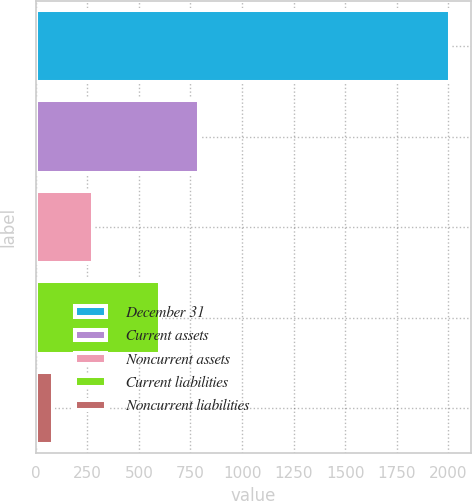Convert chart to OTSL. <chart><loc_0><loc_0><loc_500><loc_500><bar_chart><fcel>December 31<fcel>Current assets<fcel>Noncurrent assets<fcel>Current liabilities<fcel>Noncurrent liabilities<nl><fcel>2009<fcel>793.5<fcel>276.5<fcel>601<fcel>84<nl></chart> 